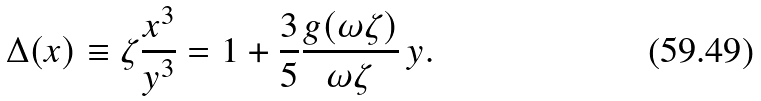Convert formula to latex. <formula><loc_0><loc_0><loc_500><loc_500>\Delta ( x ) \equiv \zeta \frac { x ^ { 3 } } { y ^ { 3 } } = 1 + \frac { 3 } { 5 } \frac { g ( \omega \zeta ) } { \omega \zeta } \, y .</formula> 